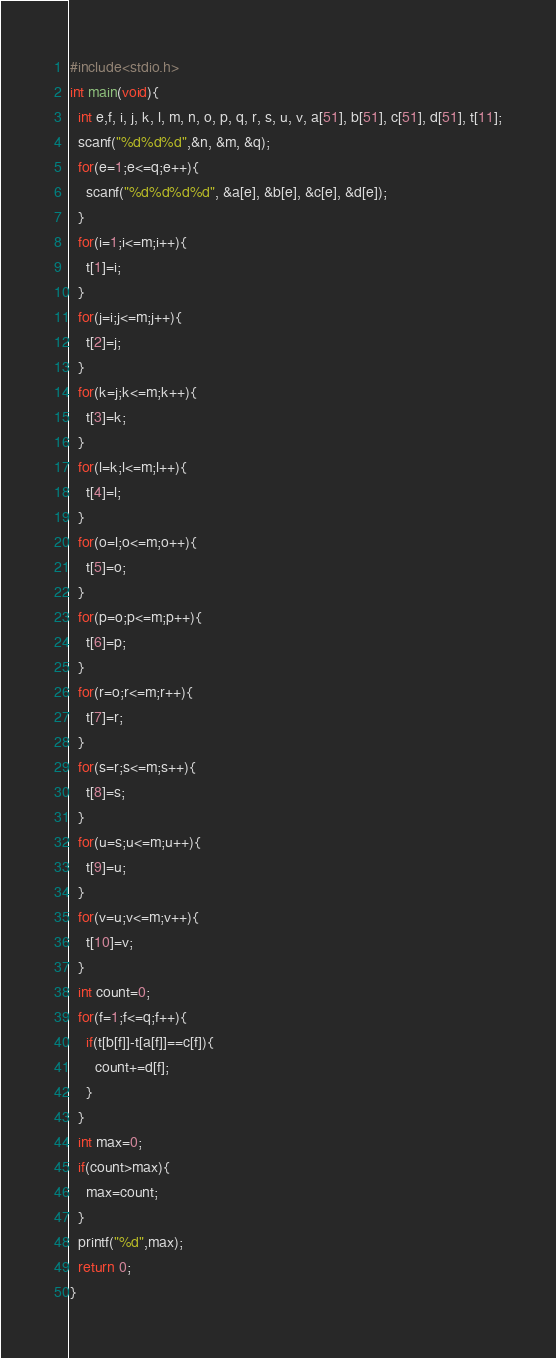<code> <loc_0><loc_0><loc_500><loc_500><_C_>#include<stdio.h>
int main(void){
  int e,f, i, j, k, l, m, n, o, p, q, r, s, u, v, a[51], b[51], c[51], d[51], t[11];
  scanf("%d%d%d",&n, &m, &q);
  for(e=1;e<=q;e++){
    scanf("%d%d%d%d", &a[e], &b[e], &c[e], &d[e]);
  }
  for(i=1;i<=m;i++){
    t[1]=i;
  }
  for(j=i;j<=m;j++){
    t[2]=j;
  }
  for(k=j;k<=m;k++){
    t[3]=k;
  }
  for(l=k;l<=m;l++){
    t[4]=l;
  }
  for(o=l;o<=m;o++){
    t[5]=o;
  }
  for(p=o;p<=m;p++){
    t[6]=p;
  }
  for(r=o;r<=m;r++){
    t[7]=r;
  }
  for(s=r;s<=m;s++){
    t[8]=s;
  }
  for(u=s;u<=m;u++){
    t[9]=u;
  }
  for(v=u;v<=m;v++){
    t[10]=v;
  }
  int count=0;
  for(f=1;f<=q;f++){
    if(t[b[f]]-t[a[f]]==c[f]){
      count+=d[f];
    }
  }
  int max=0;
  if(count>max){
    max=count;
  }
  printf("%d",max);      
  return 0;
}
</code> 